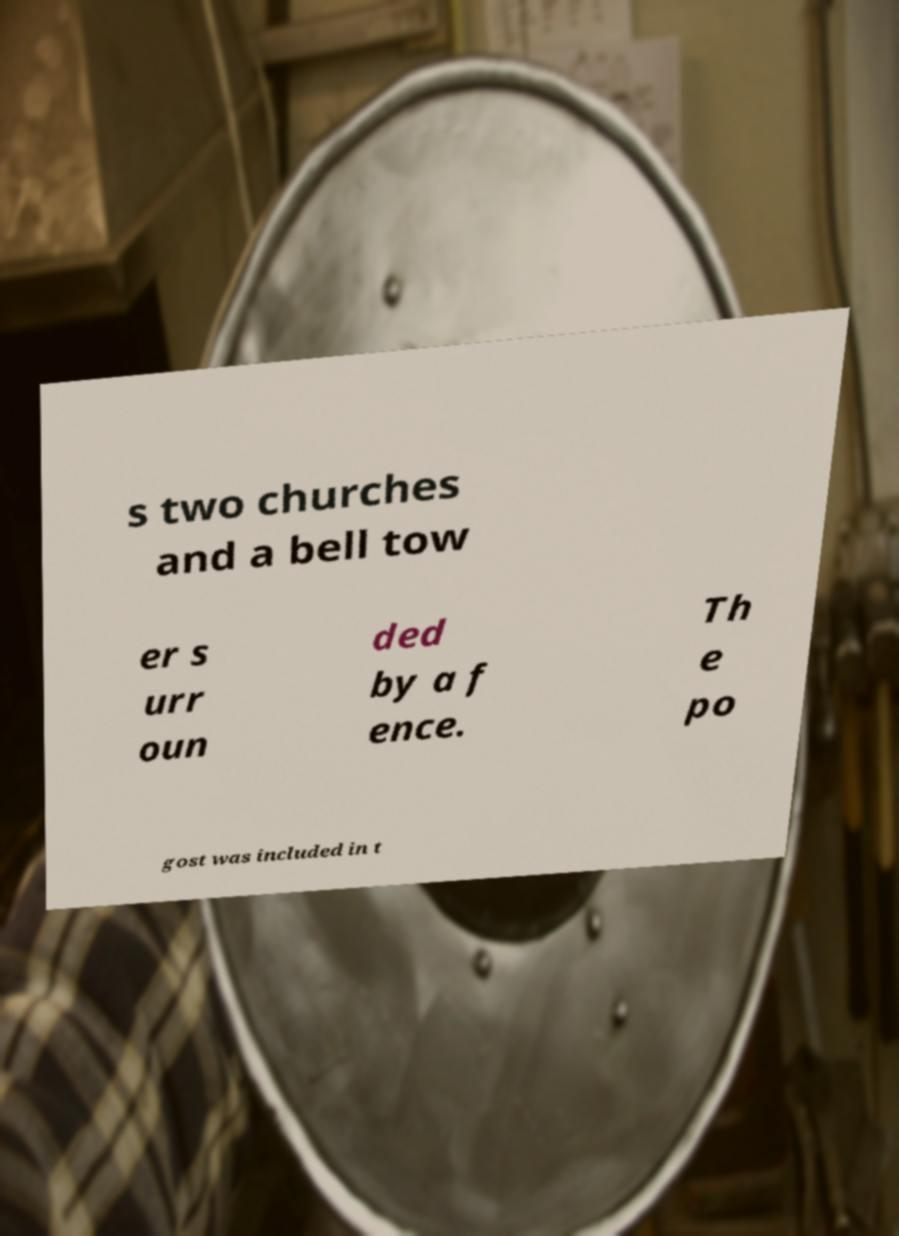Could you assist in decoding the text presented in this image and type it out clearly? s two churches and a bell tow er s urr oun ded by a f ence. Th e po gost was included in t 